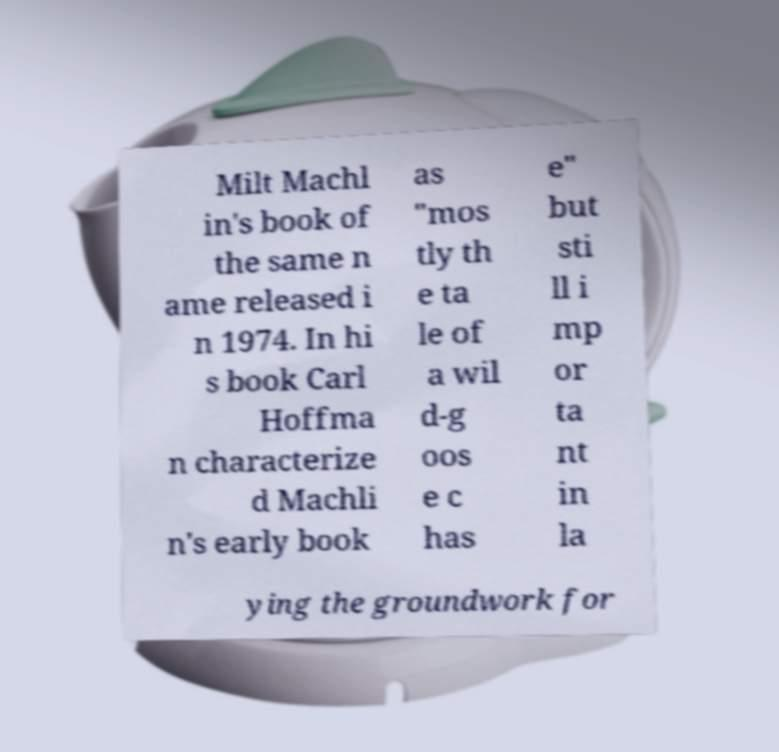Please identify and transcribe the text found in this image. Milt Machl in's book of the same n ame released i n 1974. In hi s book Carl Hoffma n characterize d Machli n's early book as "mos tly th e ta le of a wil d-g oos e c has e" but sti ll i mp or ta nt in la ying the groundwork for 